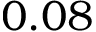Convert formula to latex. <formula><loc_0><loc_0><loc_500><loc_500>0 . 0 8</formula> 